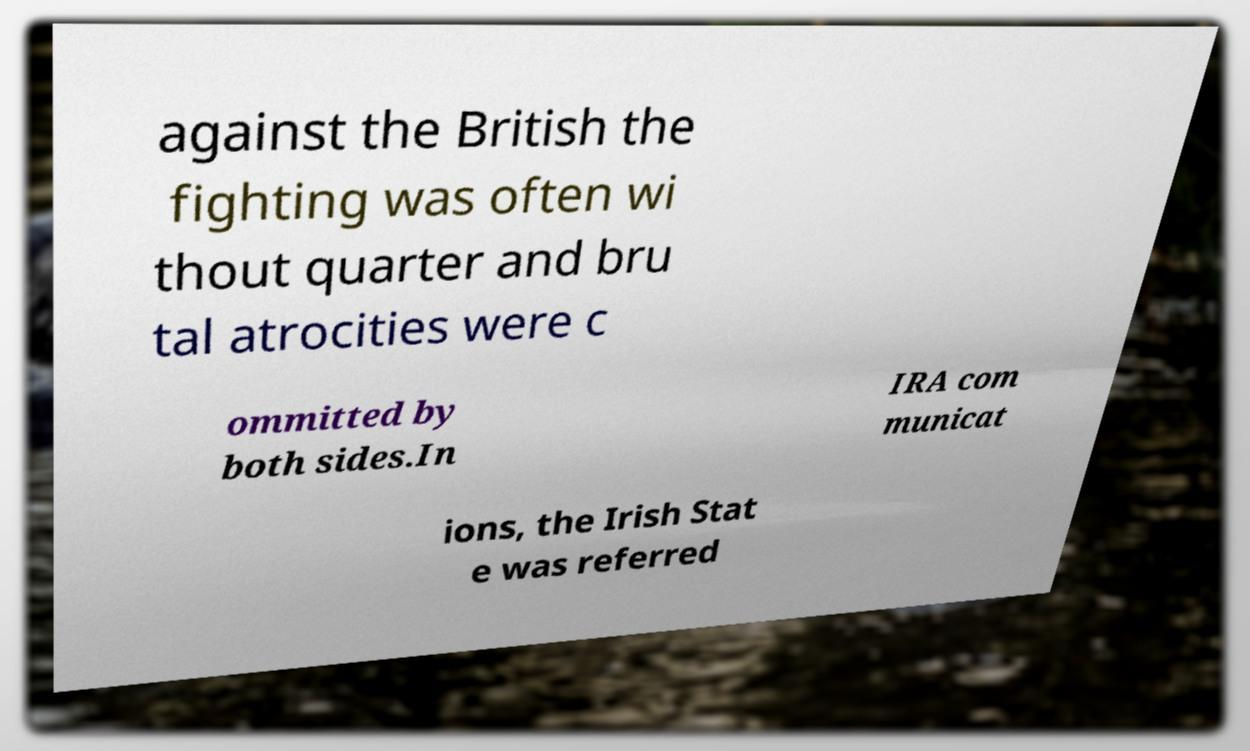Can you read and provide the text displayed in the image?This photo seems to have some interesting text. Can you extract and type it out for me? against the British the fighting was often wi thout quarter and bru tal atrocities were c ommitted by both sides.In IRA com municat ions, the Irish Stat e was referred 